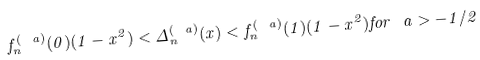<formula> <loc_0><loc_0><loc_500><loc_500>f _ { n } ^ { ( \ a ) } ( 0 ) ( 1 - x ^ { 2 } ) < \Delta ^ { ( \ a ) } _ { n } ( x ) < f _ { n } ^ { ( \ a ) } ( 1 ) ( 1 - x ^ { 2 } ) f o r \ a > - 1 / 2</formula> 